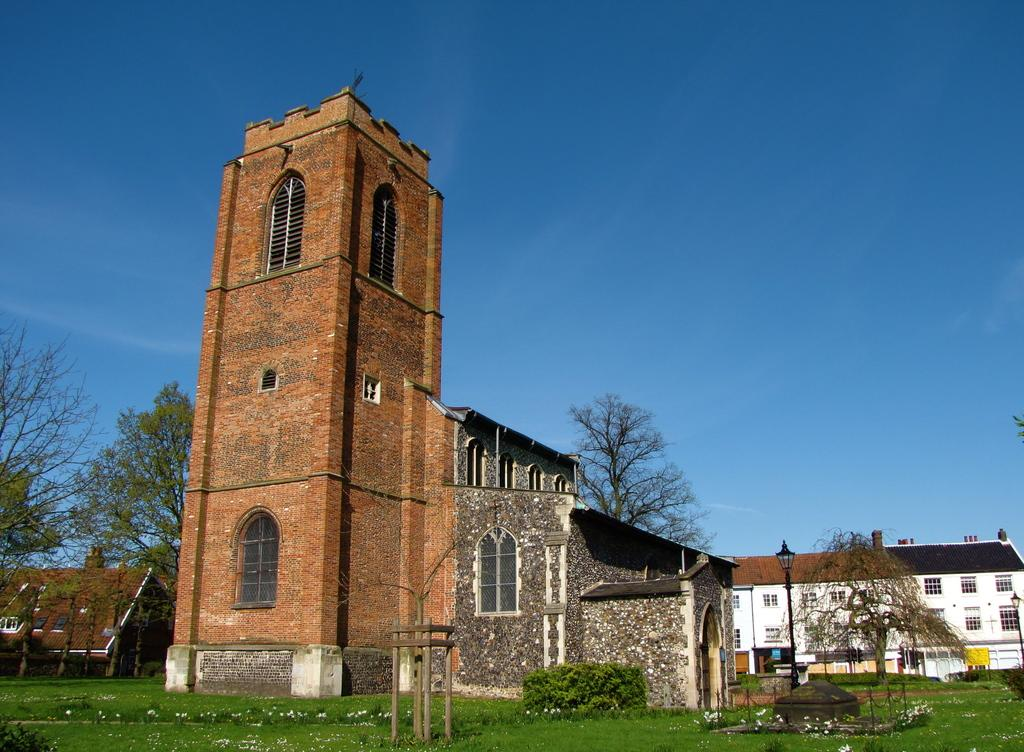What type of vegetation is present in the image? There is grass in the image. What structure can be seen in the image? There is a pole in the image. What type of man-made structures are visible in the image? There are buildings in the image. What other type of vegetation is present in the image besides grass? There are trees in the image. Can you tell me how many pears are hanging from the pole in the image? There are no pears present in the image; it features grass, a pole, buildings, and trees. What type of arch can be seen in the image? There is no arch present in the image. 